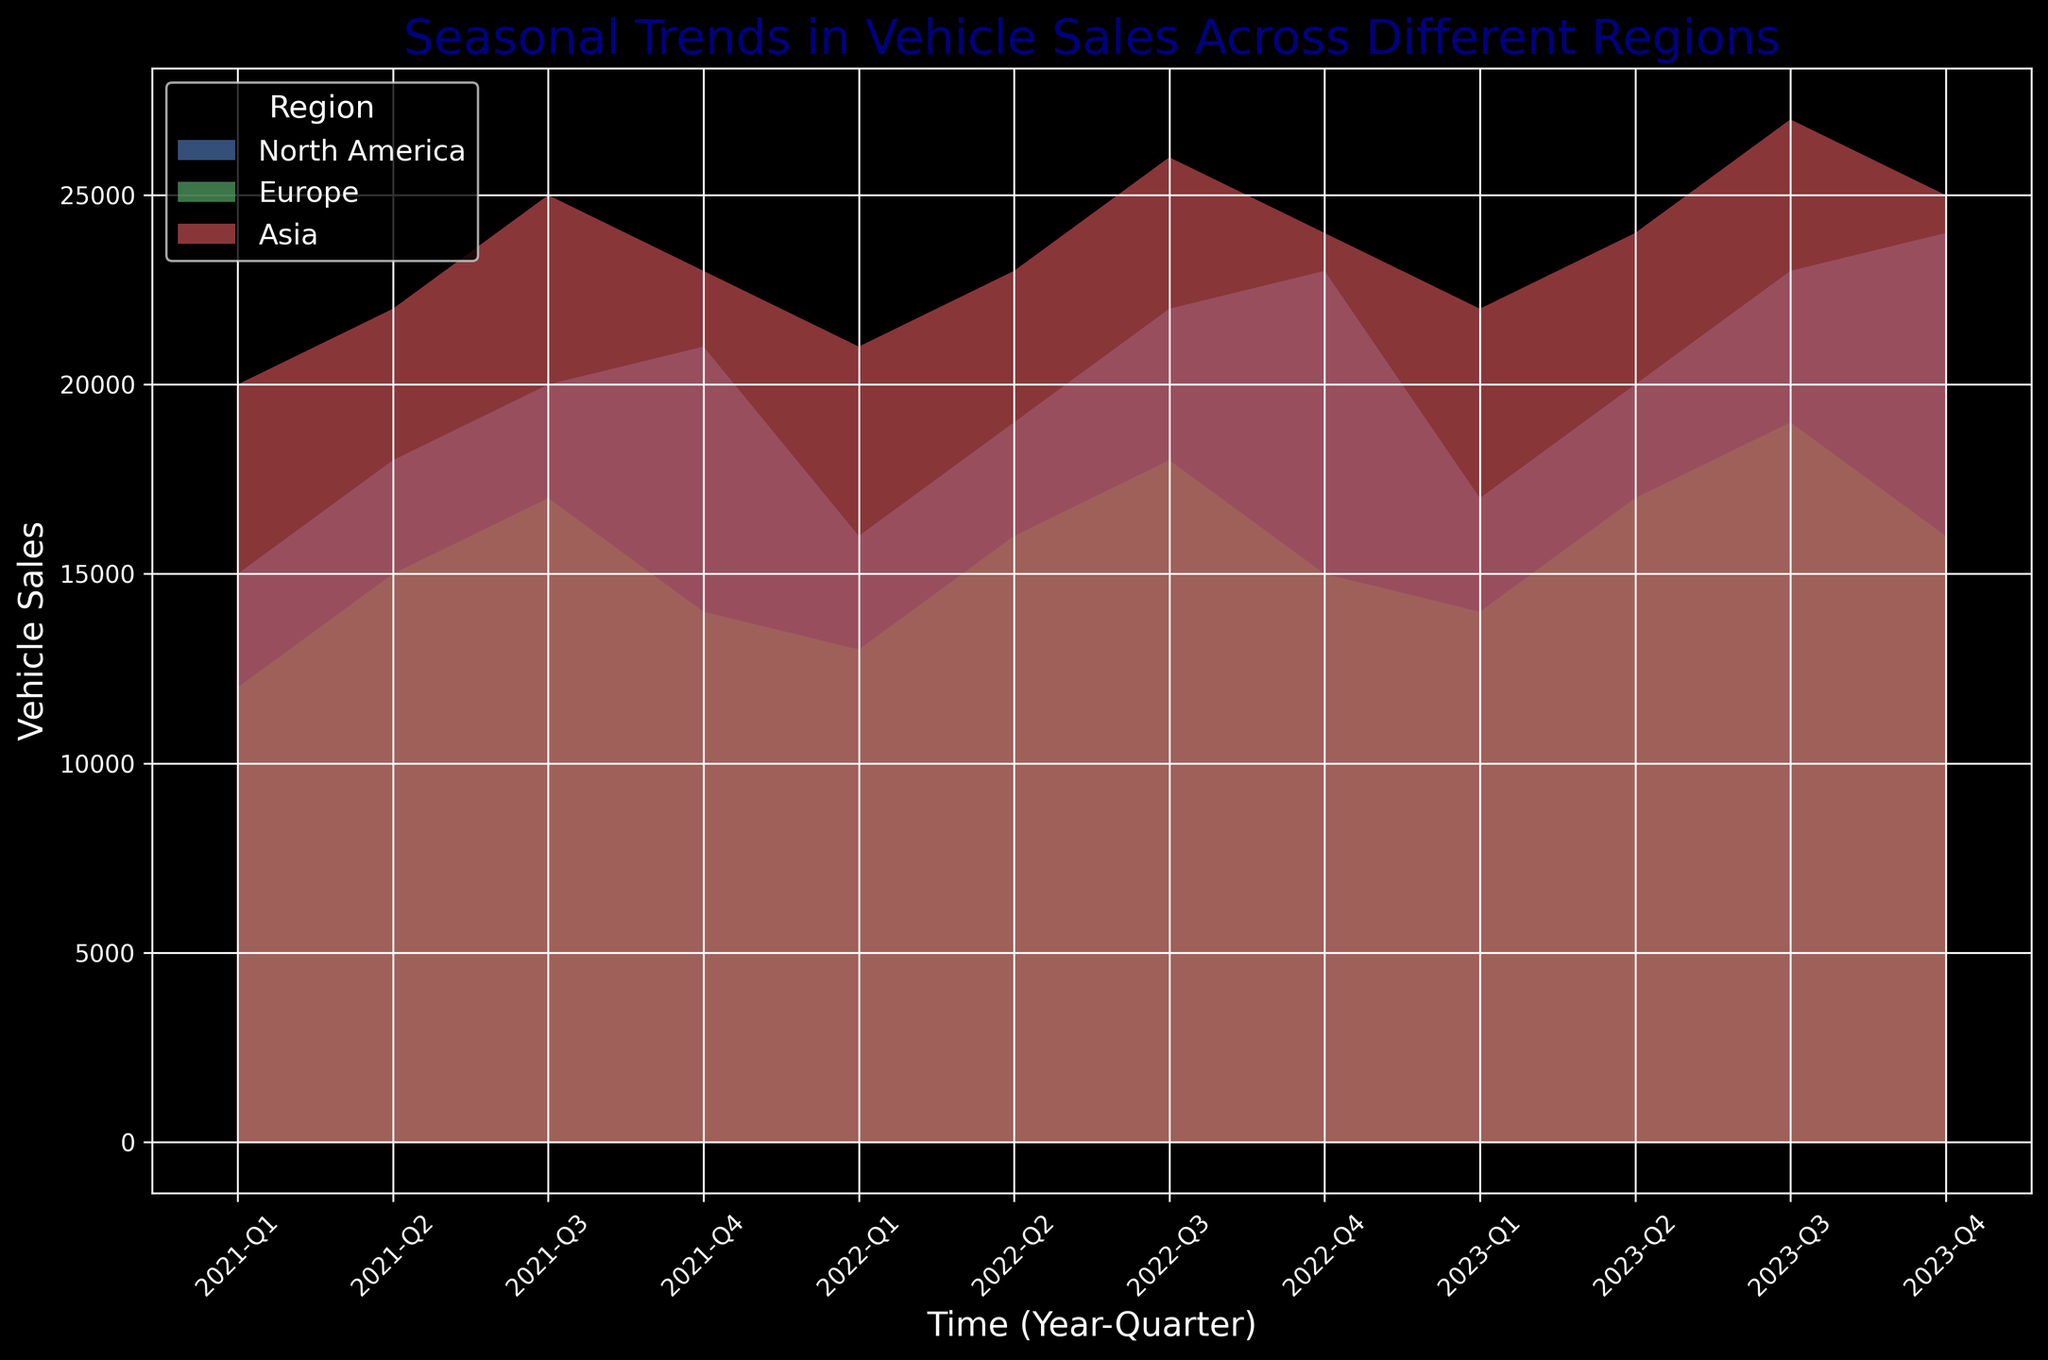What is the highest vehicle sales in a single quarter for North America? To find the highest vehicle sales in a single quarter for North America, look at the filled area representing North America in the plot. The highest point reached is 24,000 in Q4 2023.
Answer: 24,000 Which region showed the most consistent increase in vehicle sales over the three-year period? Observe the trends in the area chart. Asia shows a consistent increase without any major dips, while North America and Europe show more variability with some decreases.
Answer: Asia What was the difference in vehicle sales between Asia and Europe in Q2 2022? Locate Q2 2022 on the x-axis and find the values for Asia (23,000) and Europe (16,000). The difference is 23,000 - 16,000 = 7,000.
Answer: 7,000 Which region experienced a decline in vehicle sales during Q4 2021 to Q1 2022? Compare the filled areas from Q4 2021 to Q1 2022. North America and Asia show increases, while Europe shows a decline from 14,000 to 13,000.
Answer: Europe What's the average vehicle sales in Q3 for all regions combined over the three years? Sum the Q3 vehicle sales for all regions for 2021, 2022, and 2023. For North America: 2021 (20,000), 2022 (22,000), 2023 (23,000). For Europe: 2021 (17,000), 2022 (18,000), 2023 (19,000). For Asia: 2021 (25,000), 2022 (26,000), 2023 (27,000). Total is 20,000 + 22,000 + 23,000 + 17,000 + 18,000 + 19,000 + 25,000 + 26,000 + 27,000 = 197,000. Divide by 9 (3 years for 3 regions): 197,000 / 9 ≈ 21,889.
Answer: 21,889 Which quarter and year had the lowest sales for Europe? Look for the lowest point in the filled area representing Europe. Q1 2021 had the lowest sales with 12,000 vehicles.
Answer: Q1 2021 In which quarter did North America surpass 20,000 vehicle sales for the first time? North America surpassed 20,000 vehicle sales in Q3 2021.
Answer: Q3 2021 How much did vehicle sales in North America increase from Q1 2021 to Q1 2023? Compare Q1 2021 (15,000) to Q1 2023 (17,000). The increase is 17,000 - 15,000 = 2,000.
Answer: 2,000 